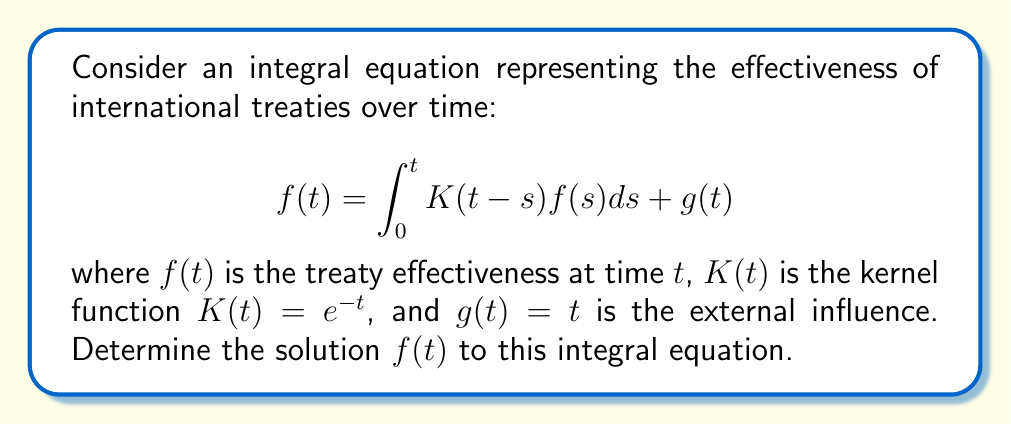Provide a solution to this math problem. 1) This is a Volterra integral equation of the second kind. To solve it, we'll use the Laplace transform method.

2) Let's denote the Laplace transform of $f(t)$ as $F(s)$. Taking the Laplace transform of both sides:

   $$\mathcal{L}\{f(t)\} = \mathcal{L}\{\int_0^t K(t-s)f(s)ds\} + \mathcal{L}\{g(t)\}$$

3) Using the convolution property of Laplace transforms:

   $$F(s) = \mathcal{L}\{K(t)\} \cdot F(s) + \mathcal{L}\{g(t)\}$$

4) We know that $\mathcal{L}\{e^{-t}\} = \frac{1}{s+1}$ and $\mathcal{L}\{t\} = \frac{1}{s^2}$. Substituting:

   $$F(s) = \frac{1}{s+1} \cdot F(s) + \frac{1}{s^2}$$

5) Solving for $F(s)$:

   $$F(s) - \frac{1}{s+1} \cdot F(s) = \frac{1}{s^2}$$
   $$F(s) \cdot (1 - \frac{1}{s+1}) = \frac{1}{s^2}$$
   $$F(s) \cdot (\frac{s}{s+1}) = \frac{1}{s^2}$$
   $$F(s) = \frac{s+1}{s^3}$$

6) Now we need to find the inverse Laplace transform of $F(s)$. We can use partial fraction decomposition:

   $$\frac{s+1}{s^3} = \frac{A}{s} + \frac{B}{s^2} + \frac{C}{s^3}$$

   Solving this, we get $A=1$, $B=1$, and $C=1$.

7) Taking the inverse Laplace transform:

   $$f(t) = \mathcal{L}^{-1}\{\frac{1}{s} + \frac{1}{s^2} + \frac{1}{s^3}\} = 1 + t + \frac{t^2}{2}$$

Thus, the solution to the integral equation is $f(t) = 1 + t + \frac{t^2}{2}$.
Answer: $f(t) = 1 + t + \frac{t^2}{2}$ 